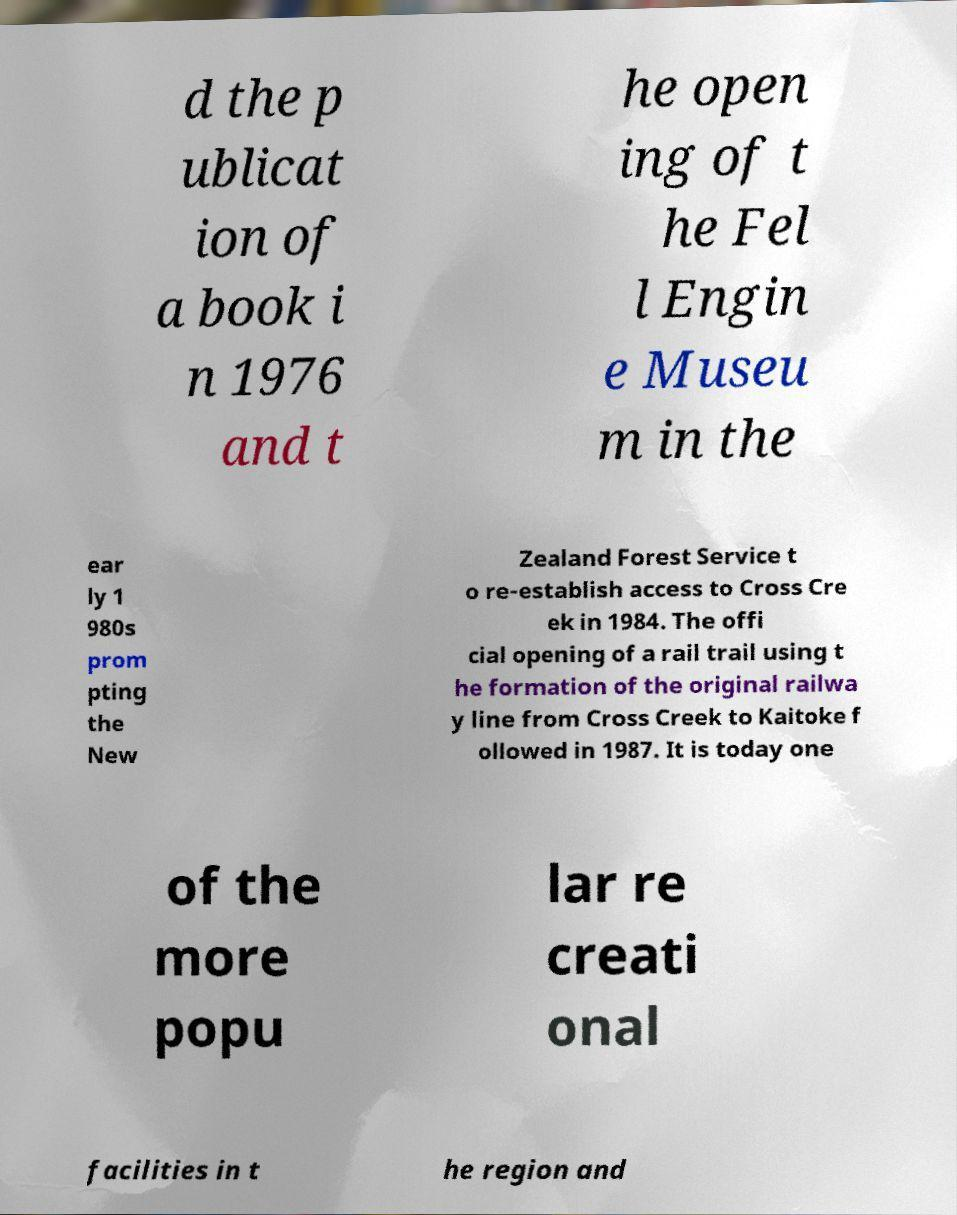Could you assist in decoding the text presented in this image and type it out clearly? d the p ublicat ion of a book i n 1976 and t he open ing of t he Fel l Engin e Museu m in the ear ly 1 980s prom pting the New Zealand Forest Service t o re-establish access to Cross Cre ek in 1984. The offi cial opening of a rail trail using t he formation of the original railwa y line from Cross Creek to Kaitoke f ollowed in 1987. It is today one of the more popu lar re creati onal facilities in t he region and 